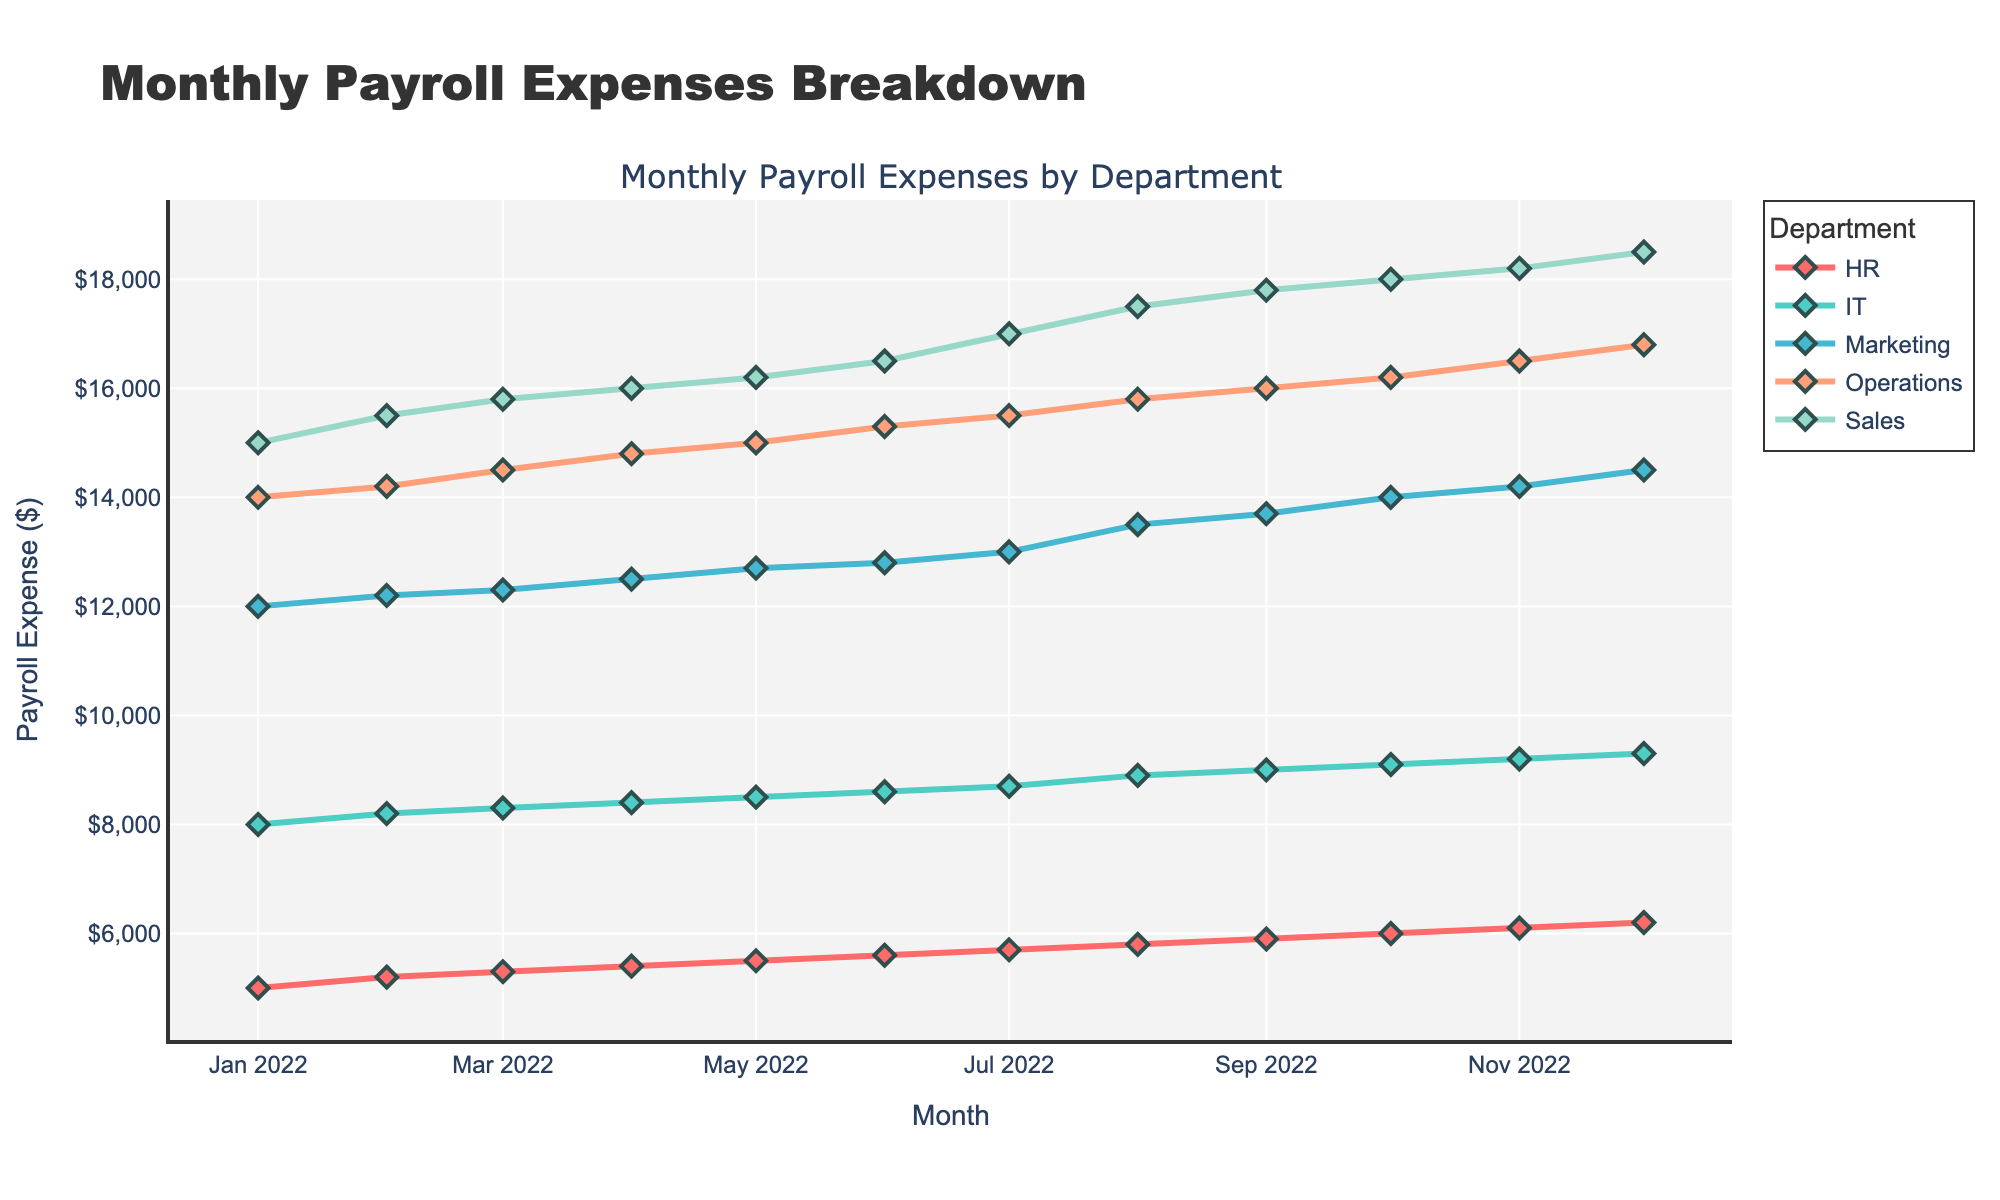What is the title of the plot? The plot title is displayed prominently at the top and reads "Monthly Payroll Expenses Breakdown."
Answer: Monthly Payroll Expenses Breakdown How many departments are shown in the plot? The legend indicates the different departments, each with a unique color. By counting them, we see there are five departments.
Answer: 5 What department had the highest payroll expense in December 2022? In December 2022, the highest line on the y-axis in the graph corresponds to the Sales department as indicated by the legend.
Answer: Sales What is the overall trend of the payroll expenses for the IT department from January to December 2022? The line representing the IT department generally trends upwards from January ($8000) to December ($9300), indicating a gradual increase.
Answer: Increasing Which month shows the biggest increase in payroll expenses for the Sales department compared to the previous month? Checking month to month, the biggest jump occurs from July ($17000) to August ($17500), a $500 increase.
Answer: August What is the total payroll expense for Marketing in the first quarter of 2022 (January, February, and March)? Adding the payroll expenses for Marketing in January ($12000), February ($12200), and March ($12300) results in a sum of $36500.
Answer: $36500 Compare the payroll expense changes between the Operations and HR departments from January to December 2022. The Operations department starts at $14000 in January and ends at $16800 in December, showing a $2800 increase. The HR department starts at $5000 in January and ends at $6200 in December, showing a $1200 increase. Operations increased more than HR.
Answer: Operations increased more than HR Which department had the smallest payroll expense in July 2022? Looking at July 2022, the lowest point on the y-axis graph corresponds to the HR department, which is shown as $5700.
Answer: HR During which months did the payroll expense for the Marketing department surpass $14000? The Marketing department's line surpasses the $14000 mark in October, November, and December 2022, as indicated by the y-axis points.
Answer: October, November, and December What is the average payroll expense for the Operations department over the entire year of 2022? The payroll expenses for Operations listed are $14000, $14200, $14500, $14800, $15000, $15300, $15500, $15800, $16000, $16200, $16500, and $16800. Summing these amounts and dividing by 12 gives an average. Total = $182500, Average = $15208.33.
Answer: $15208.33 